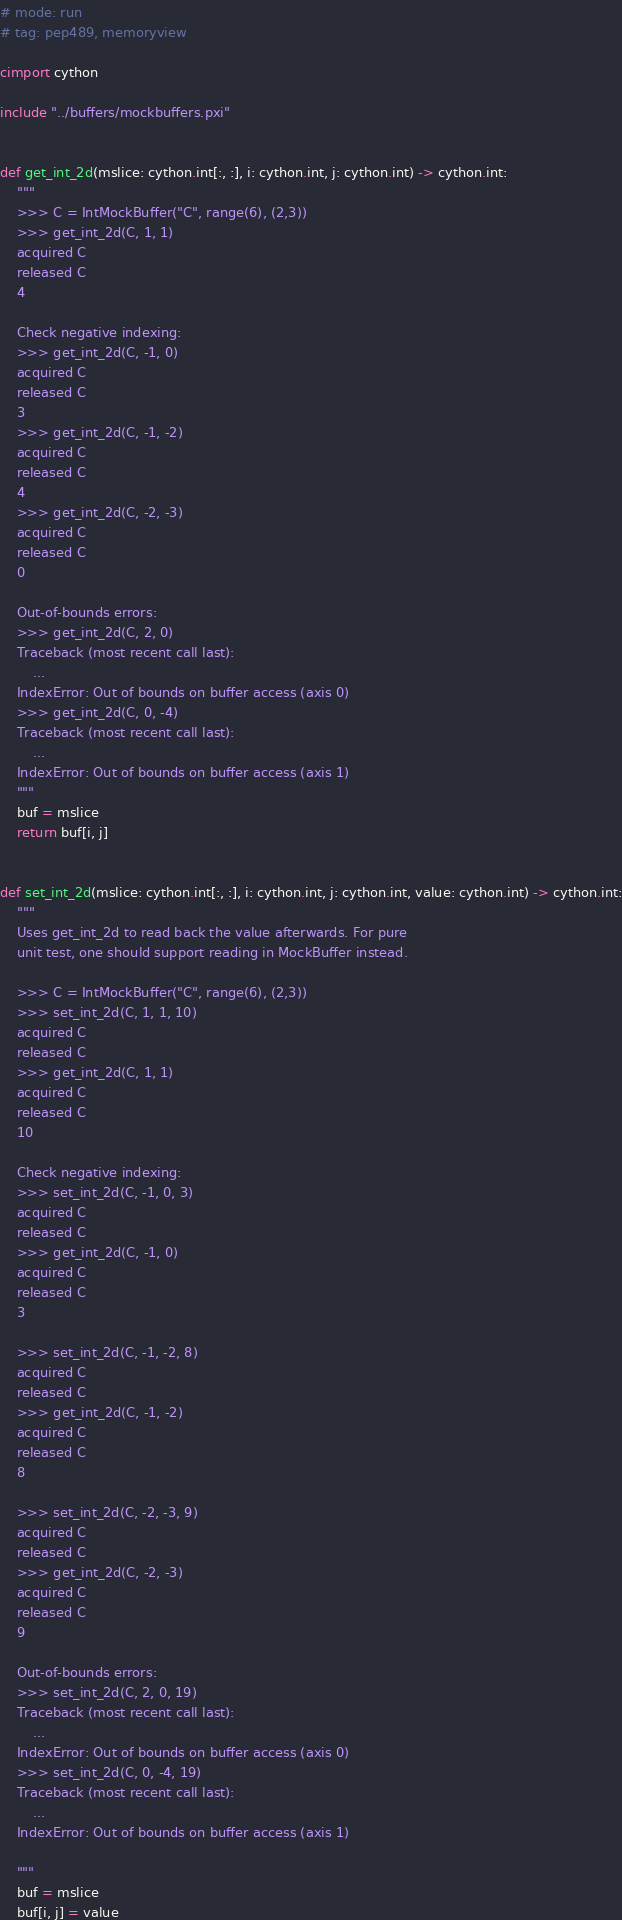Convert code to text. <code><loc_0><loc_0><loc_500><loc_500><_Cython_># mode: run
# tag: pep489, memoryview

cimport cython

include "../buffers/mockbuffers.pxi"


def get_int_2d(mslice: cython.int[:, :], i: cython.int, j: cython.int) -> cython.int:
    """
    >>> C = IntMockBuffer("C", range(6), (2,3))
    >>> get_int_2d(C, 1, 1)
    acquired C
    released C
    4

    Check negative indexing:
    >>> get_int_2d(C, -1, 0)
    acquired C
    released C
    3
    >>> get_int_2d(C, -1, -2)
    acquired C
    released C
    4
    >>> get_int_2d(C, -2, -3)
    acquired C
    released C
    0

    Out-of-bounds errors:
    >>> get_int_2d(C, 2, 0)
    Traceback (most recent call last):
        ...
    IndexError: Out of bounds on buffer access (axis 0)
    >>> get_int_2d(C, 0, -4)
    Traceback (most recent call last):
        ...
    IndexError: Out of bounds on buffer access (axis 1)
    """
    buf = mslice
    return buf[i, j]


def set_int_2d(mslice: cython.int[:, :], i: cython.int, j: cython.int, value: cython.int) -> cython.int:
    """
    Uses get_int_2d to read back the value afterwards. For pure
    unit test, one should support reading in MockBuffer instead.

    >>> C = IntMockBuffer("C", range(6), (2,3))
    >>> set_int_2d(C, 1, 1, 10)
    acquired C
    released C
    >>> get_int_2d(C, 1, 1)
    acquired C
    released C
    10

    Check negative indexing:
    >>> set_int_2d(C, -1, 0, 3)
    acquired C
    released C
    >>> get_int_2d(C, -1, 0)
    acquired C
    released C
    3

    >>> set_int_2d(C, -1, -2, 8)
    acquired C
    released C
    >>> get_int_2d(C, -1, -2)
    acquired C
    released C
    8

    >>> set_int_2d(C, -2, -3, 9)
    acquired C
    released C
    >>> get_int_2d(C, -2, -3)
    acquired C
    released C
    9

    Out-of-bounds errors:
    >>> set_int_2d(C, 2, 0, 19)
    Traceback (most recent call last):
        ...
    IndexError: Out of bounds on buffer access (axis 0)
    >>> set_int_2d(C, 0, -4, 19)
    Traceback (most recent call last):
        ...
    IndexError: Out of bounds on buffer access (axis 1)

    """
    buf = mslice
    buf[i, j] = value
</code> 